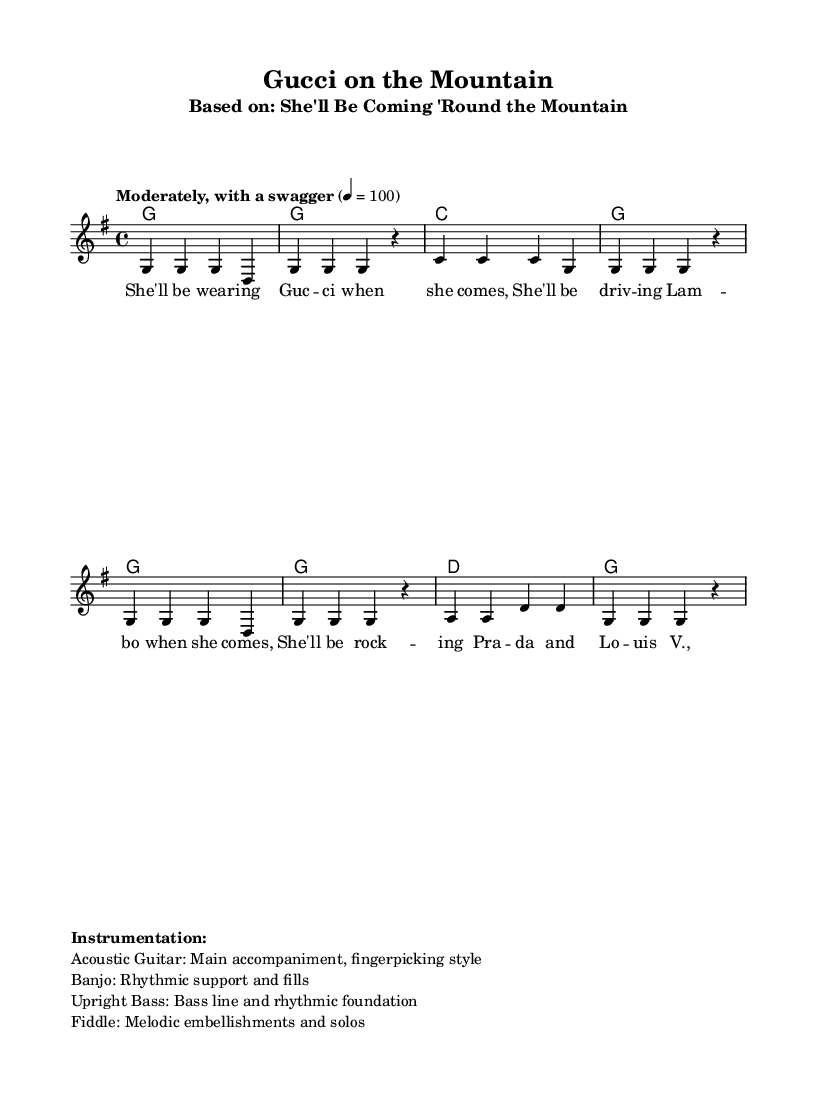What is the key signature of this music? The key signature is G major, which has one sharp (F#). It's indicated at the beginning of the music sheet.
Answer: G major What is the time signature of this music? The time signature is 4/4, which means there are four beats in each measure. This can be seen right at the beginning of the score.
Answer: 4/4 What is the tempo marking for this piece? The tempo marking states "Moderately, with a swagger" and indicates a speed of 100 beats per minute, which sets the overall pace of the song.
Answer: Moderately, with a swagger How many measures are in the melody section? The melody section has a total of 8 measures, which can be counted by looking at the bars in the melody line.
Answer: 8 measures What brand is mentioned in the first line of the lyrics? The first line of the lyrics mentions "Gucci," indicating a designer reference that sets the theme of luxury within the folk song.
Answer: Gucci Which instruments are listed in the instrumentation? The instruments listed include Acoustic Guitar, Banjo, Upright Bass, and Fiddle. These instruments characterize the folk genre.
Answer: Acoustic Guitar, Banjo, Upright Bass, Fiddle What is the last designer brand mentioned in the lyrics? The last designer brand mentioned is "Louis V.," which is an abbreviated form of Louis Vuitton, known for its luxury fashion.
Answer: Louis V 